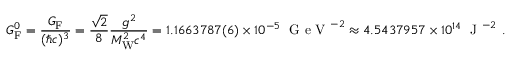<formula> <loc_0><loc_0><loc_500><loc_500>G _ { F } ^ { 0 } = { \frac { G _ { F } } { ( \hbar { c } ) ^ { 3 } } } = { \frac { \sqrt { 2 } } { 8 } } { \frac { g ^ { 2 } } { M _ { W } ^ { 2 } c ^ { 4 } } } = 1 . 1 6 6 3 7 8 7 ( 6 ) \times 1 0 ^ { - 5 } \, { G e V } ^ { - 2 } \approx 4 . 5 4 3 7 9 5 7 \times 1 0 ^ { 1 4 } \, { J } ^ { - 2 } \ .</formula> 